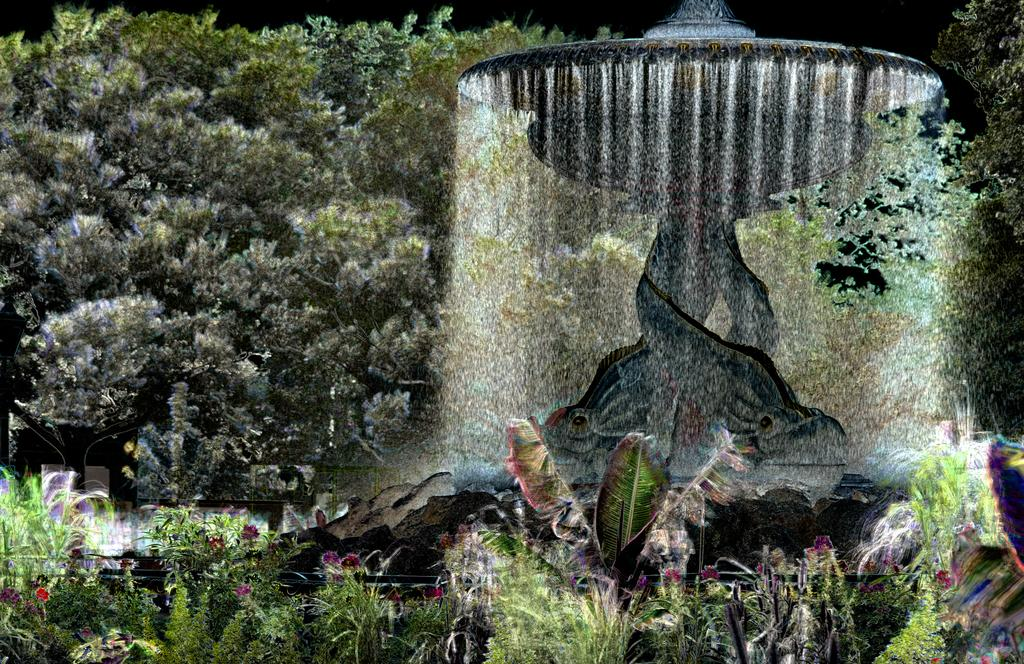What type of vegetation can be seen in the image? There are trees and plants in the image. What is located in the middle of the image? There is a fountain in the middle of the image. What scent can be detected from the sheep in the image? There are no sheep present in the image, so no scent can be detected. 